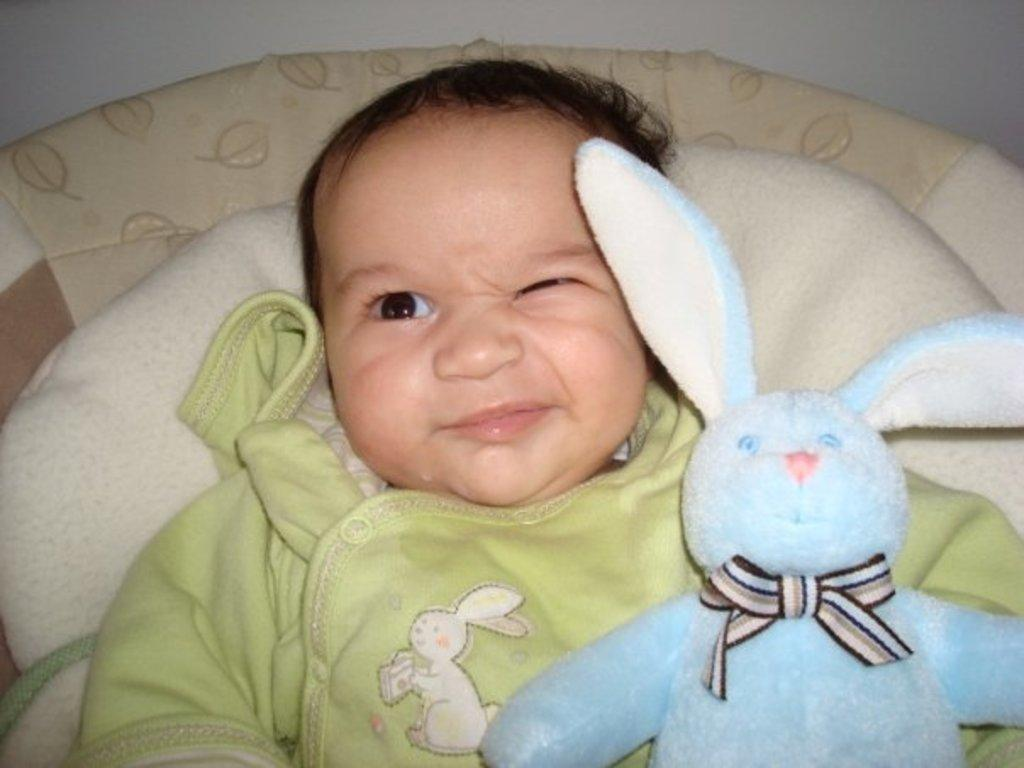What is the main subject of the image? There is a baby in the image. What is the baby's position in the image? The baby is laying down. What other object is present in the image? There is a teddy bear in the image. What can be seen in the background of the image? There is a wall in the background of the image. What is the condition of the sky in the image? There is no sky visible in the image; it only shows a baby laying down, a teddy bear, and a wall in the background. 